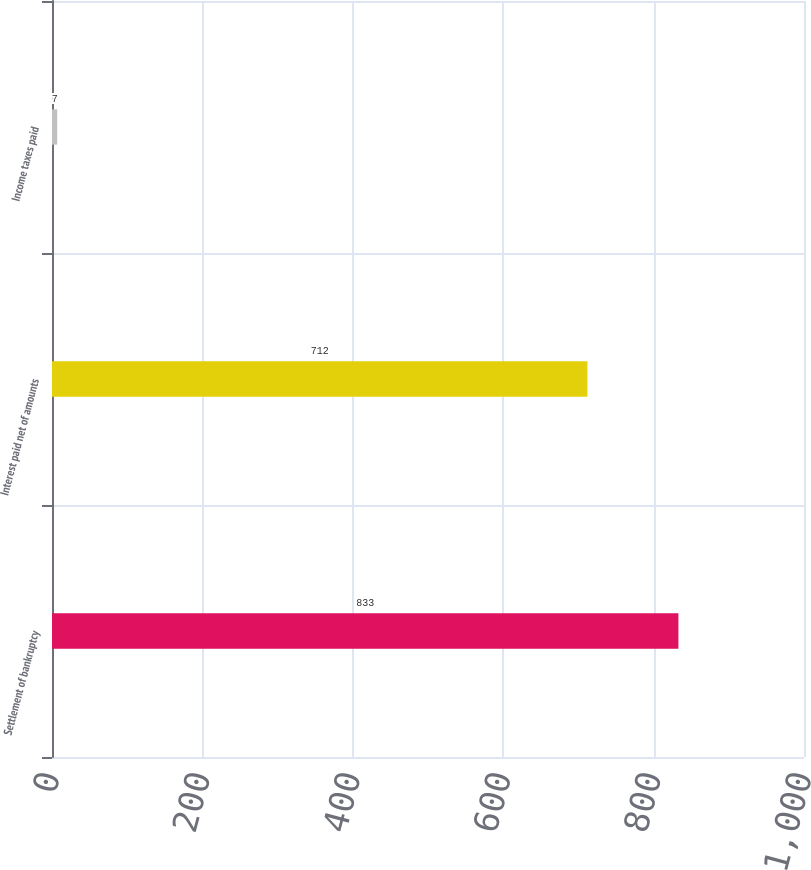Convert chart. <chart><loc_0><loc_0><loc_500><loc_500><bar_chart><fcel>Settlement of bankruptcy<fcel>Interest paid net of amounts<fcel>Income taxes paid<nl><fcel>833<fcel>712<fcel>7<nl></chart> 